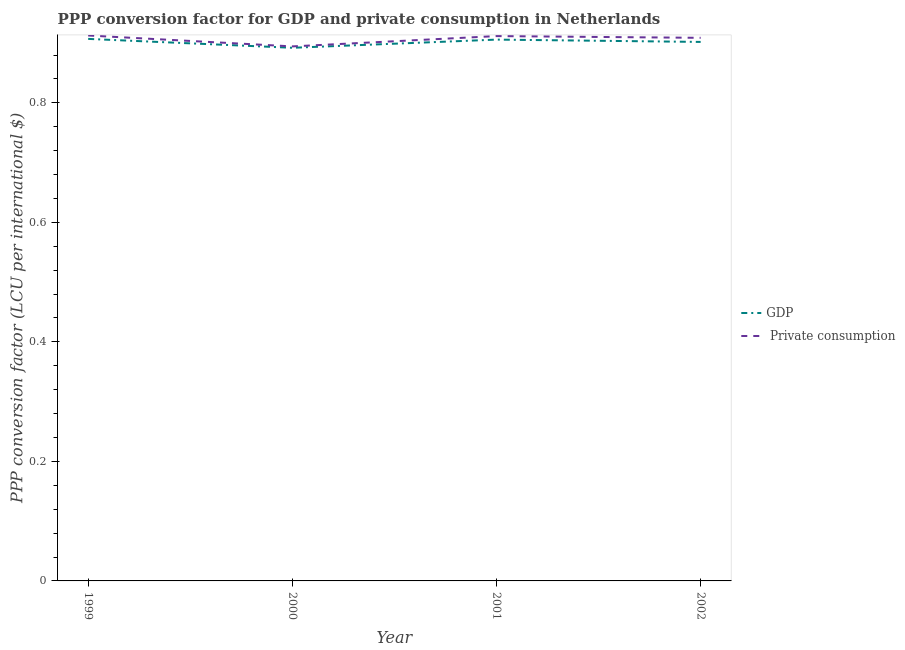How many different coloured lines are there?
Your answer should be very brief. 2. What is the ppp conversion factor for gdp in 2001?
Give a very brief answer. 0.91. Across all years, what is the maximum ppp conversion factor for private consumption?
Keep it short and to the point. 0.91. Across all years, what is the minimum ppp conversion factor for gdp?
Keep it short and to the point. 0.89. In which year was the ppp conversion factor for private consumption maximum?
Offer a terse response. 1999. In which year was the ppp conversion factor for private consumption minimum?
Your answer should be compact. 2000. What is the total ppp conversion factor for private consumption in the graph?
Provide a succinct answer. 3.63. What is the difference between the ppp conversion factor for private consumption in 1999 and that in 2001?
Your response must be concise. 0. What is the difference between the ppp conversion factor for gdp in 1999 and the ppp conversion factor for private consumption in 2000?
Offer a terse response. 0.01. What is the average ppp conversion factor for gdp per year?
Your response must be concise. 0.9. In the year 2000, what is the difference between the ppp conversion factor for gdp and ppp conversion factor for private consumption?
Give a very brief answer. -0. In how many years, is the ppp conversion factor for gdp greater than 0.6400000000000001 LCU?
Ensure brevity in your answer.  4. What is the ratio of the ppp conversion factor for private consumption in 2000 to that in 2002?
Provide a succinct answer. 0.98. Is the ppp conversion factor for private consumption in 2000 less than that in 2001?
Provide a succinct answer. Yes. What is the difference between the highest and the second highest ppp conversion factor for private consumption?
Offer a very short reply. 0. What is the difference between the highest and the lowest ppp conversion factor for private consumption?
Your answer should be compact. 0.02. In how many years, is the ppp conversion factor for private consumption greater than the average ppp conversion factor for private consumption taken over all years?
Provide a succinct answer. 3. Does the ppp conversion factor for gdp monotonically increase over the years?
Your response must be concise. No. How many lines are there?
Offer a terse response. 2. What is the difference between two consecutive major ticks on the Y-axis?
Offer a very short reply. 0.2. Are the values on the major ticks of Y-axis written in scientific E-notation?
Your answer should be compact. No. Does the graph contain any zero values?
Offer a terse response. No. Where does the legend appear in the graph?
Provide a succinct answer. Center right. What is the title of the graph?
Keep it short and to the point. PPP conversion factor for GDP and private consumption in Netherlands. What is the label or title of the Y-axis?
Offer a very short reply. PPP conversion factor (LCU per international $). What is the PPP conversion factor (LCU per international $) in GDP in 1999?
Ensure brevity in your answer.  0.91. What is the PPP conversion factor (LCU per international $) of  Private consumption in 1999?
Provide a succinct answer. 0.91. What is the PPP conversion factor (LCU per international $) in GDP in 2000?
Make the answer very short. 0.89. What is the PPP conversion factor (LCU per international $) in  Private consumption in 2000?
Give a very brief answer. 0.89. What is the PPP conversion factor (LCU per international $) in GDP in 2001?
Make the answer very short. 0.91. What is the PPP conversion factor (LCU per international $) in  Private consumption in 2001?
Ensure brevity in your answer.  0.91. What is the PPP conversion factor (LCU per international $) of GDP in 2002?
Ensure brevity in your answer.  0.9. What is the PPP conversion factor (LCU per international $) in  Private consumption in 2002?
Offer a very short reply. 0.91. Across all years, what is the maximum PPP conversion factor (LCU per international $) of GDP?
Offer a terse response. 0.91. Across all years, what is the maximum PPP conversion factor (LCU per international $) in  Private consumption?
Your answer should be compact. 0.91. Across all years, what is the minimum PPP conversion factor (LCU per international $) of GDP?
Ensure brevity in your answer.  0.89. Across all years, what is the minimum PPP conversion factor (LCU per international $) in  Private consumption?
Give a very brief answer. 0.89. What is the total PPP conversion factor (LCU per international $) of GDP in the graph?
Offer a very short reply. 3.61. What is the total PPP conversion factor (LCU per international $) of  Private consumption in the graph?
Keep it short and to the point. 3.63. What is the difference between the PPP conversion factor (LCU per international $) in GDP in 1999 and that in 2000?
Keep it short and to the point. 0.01. What is the difference between the PPP conversion factor (LCU per international $) in  Private consumption in 1999 and that in 2000?
Ensure brevity in your answer.  0.02. What is the difference between the PPP conversion factor (LCU per international $) of GDP in 1999 and that in 2001?
Offer a terse response. 0. What is the difference between the PPP conversion factor (LCU per international $) in  Private consumption in 1999 and that in 2001?
Provide a succinct answer. 0. What is the difference between the PPP conversion factor (LCU per international $) in GDP in 1999 and that in 2002?
Offer a terse response. 0.01. What is the difference between the PPP conversion factor (LCU per international $) of  Private consumption in 1999 and that in 2002?
Your answer should be very brief. 0. What is the difference between the PPP conversion factor (LCU per international $) of GDP in 2000 and that in 2001?
Your response must be concise. -0.01. What is the difference between the PPP conversion factor (LCU per international $) in  Private consumption in 2000 and that in 2001?
Your response must be concise. -0.02. What is the difference between the PPP conversion factor (LCU per international $) in GDP in 2000 and that in 2002?
Ensure brevity in your answer.  -0.01. What is the difference between the PPP conversion factor (LCU per international $) in  Private consumption in 2000 and that in 2002?
Provide a short and direct response. -0.01. What is the difference between the PPP conversion factor (LCU per international $) of GDP in 2001 and that in 2002?
Your answer should be compact. 0. What is the difference between the PPP conversion factor (LCU per international $) of  Private consumption in 2001 and that in 2002?
Keep it short and to the point. 0. What is the difference between the PPP conversion factor (LCU per international $) in GDP in 1999 and the PPP conversion factor (LCU per international $) in  Private consumption in 2000?
Your answer should be very brief. 0.01. What is the difference between the PPP conversion factor (LCU per international $) in GDP in 1999 and the PPP conversion factor (LCU per international $) in  Private consumption in 2001?
Offer a very short reply. -0. What is the difference between the PPP conversion factor (LCU per international $) of GDP in 1999 and the PPP conversion factor (LCU per international $) of  Private consumption in 2002?
Your answer should be compact. -0. What is the difference between the PPP conversion factor (LCU per international $) in GDP in 2000 and the PPP conversion factor (LCU per international $) in  Private consumption in 2001?
Your answer should be very brief. -0.02. What is the difference between the PPP conversion factor (LCU per international $) of GDP in 2000 and the PPP conversion factor (LCU per international $) of  Private consumption in 2002?
Keep it short and to the point. -0.02. What is the difference between the PPP conversion factor (LCU per international $) in GDP in 2001 and the PPP conversion factor (LCU per international $) in  Private consumption in 2002?
Your answer should be very brief. -0. What is the average PPP conversion factor (LCU per international $) in GDP per year?
Provide a succinct answer. 0.9. What is the average PPP conversion factor (LCU per international $) in  Private consumption per year?
Offer a very short reply. 0.91. In the year 1999, what is the difference between the PPP conversion factor (LCU per international $) in GDP and PPP conversion factor (LCU per international $) in  Private consumption?
Keep it short and to the point. -0.01. In the year 2000, what is the difference between the PPP conversion factor (LCU per international $) in GDP and PPP conversion factor (LCU per international $) in  Private consumption?
Provide a succinct answer. -0. In the year 2001, what is the difference between the PPP conversion factor (LCU per international $) in GDP and PPP conversion factor (LCU per international $) in  Private consumption?
Offer a terse response. -0.01. In the year 2002, what is the difference between the PPP conversion factor (LCU per international $) in GDP and PPP conversion factor (LCU per international $) in  Private consumption?
Your answer should be compact. -0.01. What is the ratio of the PPP conversion factor (LCU per international $) in GDP in 1999 to that in 2000?
Offer a terse response. 1.02. What is the ratio of the PPP conversion factor (LCU per international $) in  Private consumption in 1999 to that in 2000?
Offer a terse response. 1.02. What is the ratio of the PPP conversion factor (LCU per international $) in GDP in 1999 to that in 2002?
Your answer should be compact. 1.01. What is the ratio of the PPP conversion factor (LCU per international $) of GDP in 2000 to that in 2001?
Keep it short and to the point. 0.98. What is the ratio of the PPP conversion factor (LCU per international $) in  Private consumption in 2000 to that in 2001?
Ensure brevity in your answer.  0.98. What is the ratio of the PPP conversion factor (LCU per international $) of GDP in 2000 to that in 2002?
Your answer should be very brief. 0.99. What is the ratio of the PPP conversion factor (LCU per international $) in  Private consumption in 2000 to that in 2002?
Your answer should be very brief. 0.98. What is the difference between the highest and the second highest PPP conversion factor (LCU per international $) of GDP?
Provide a short and direct response. 0. What is the difference between the highest and the lowest PPP conversion factor (LCU per international $) in GDP?
Provide a short and direct response. 0.01. What is the difference between the highest and the lowest PPP conversion factor (LCU per international $) of  Private consumption?
Offer a very short reply. 0.02. 